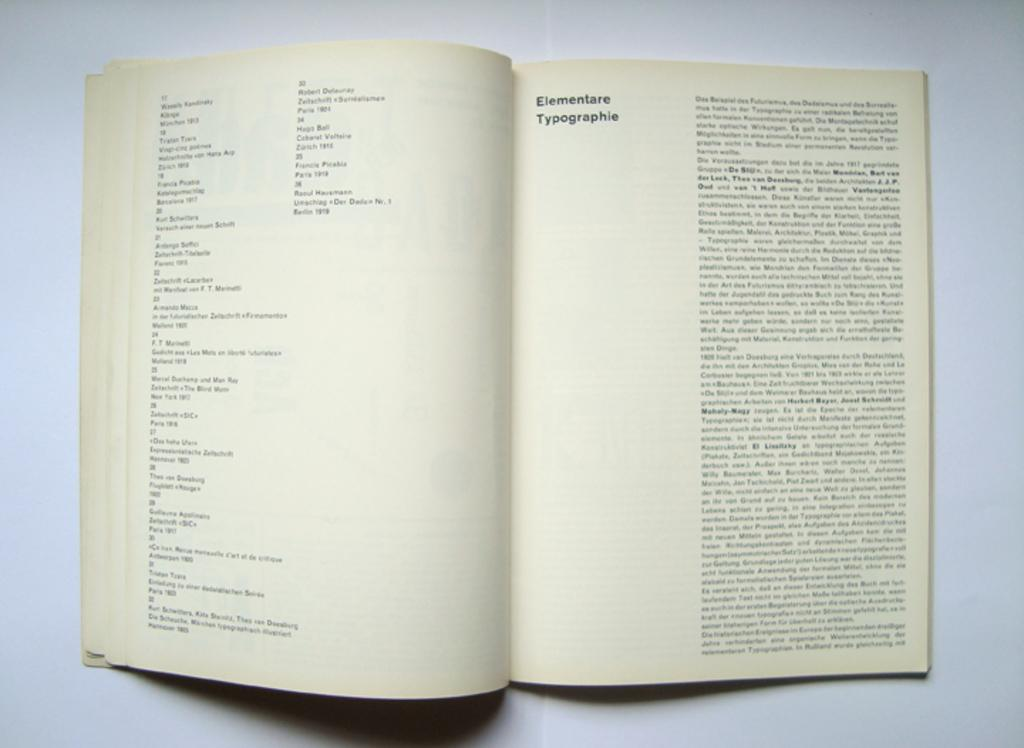<image>
Offer a succinct explanation of the picture presented. A book opened to a page about elementare typographie 